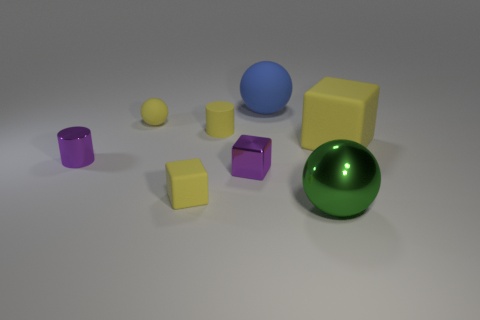Subtract 1 cubes. How many cubes are left? 2 Add 1 small yellow cylinders. How many objects exist? 9 Subtract all cylinders. How many objects are left? 6 Add 7 large yellow rubber cubes. How many large yellow rubber cubes exist? 8 Subtract 0 red balls. How many objects are left? 8 Subtract all matte cylinders. Subtract all small yellow cubes. How many objects are left? 6 Add 4 large objects. How many large objects are left? 7 